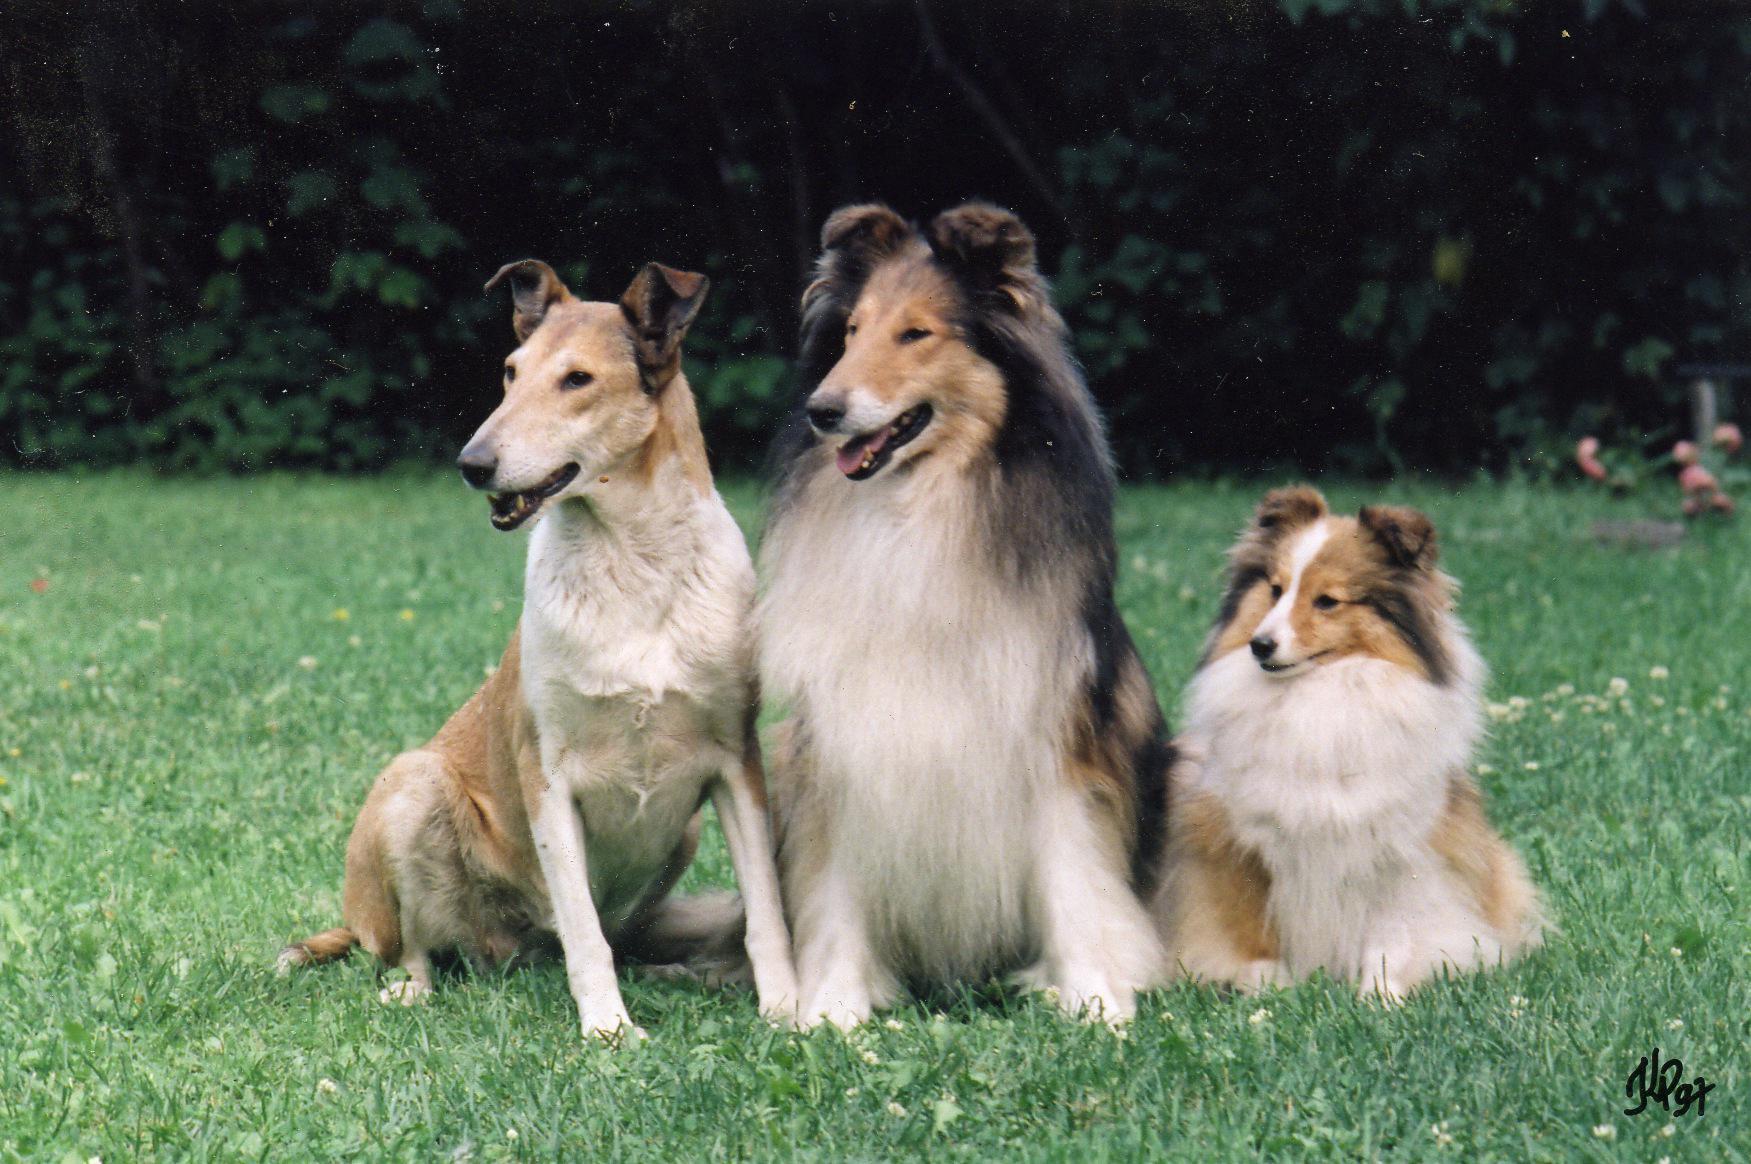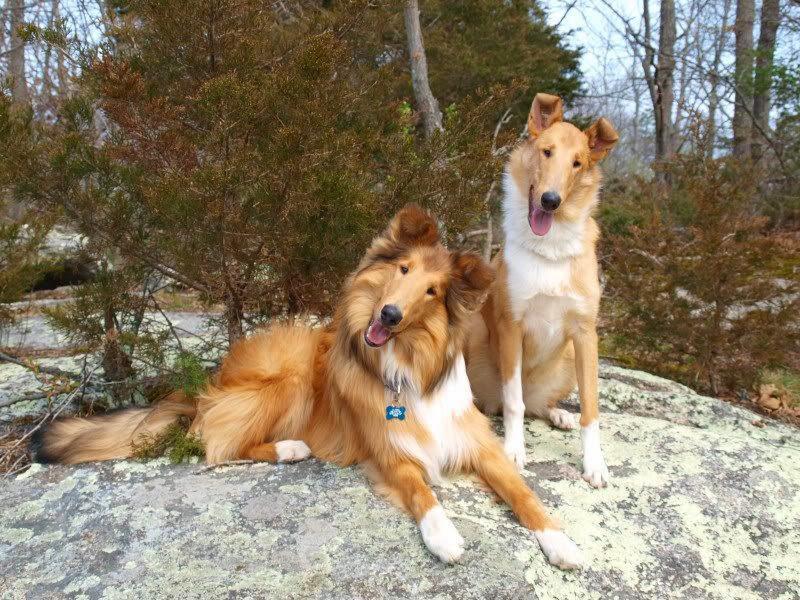The first image is the image on the left, the second image is the image on the right. Given the left and right images, does the statement "There are at most five dogs." hold true? Answer yes or no. Yes. The first image is the image on the left, the second image is the image on the right. For the images shown, is this caption "Two Collies beside each other have their heads cocked to the right." true? Answer yes or no. Yes. 